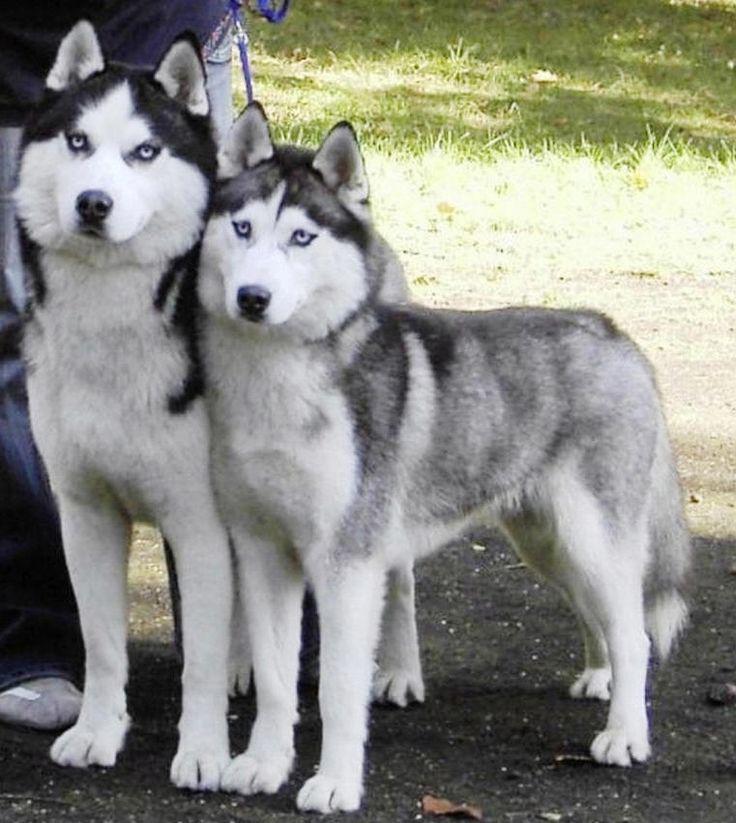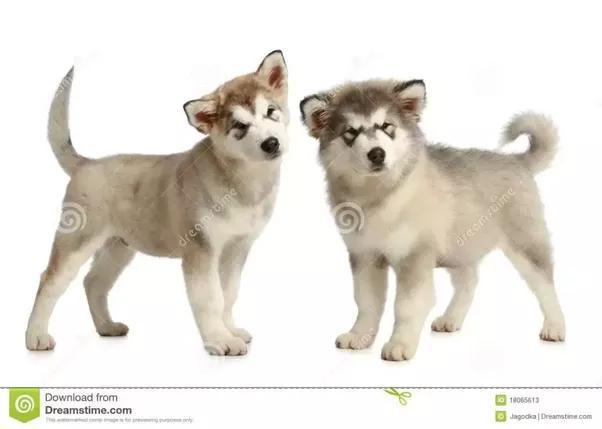The first image is the image on the left, the second image is the image on the right. Analyze the images presented: Is the assertion "In at least one image there are two dogs and at least one is a very young husky puppy." valid? Answer yes or no. Yes. The first image is the image on the left, the second image is the image on the right. Considering the images on both sides, is "The left image features two huskies side by side, with at least one sitting upright, and the right image contains two dogs, with at least one reclining." valid? Answer yes or no. No. 